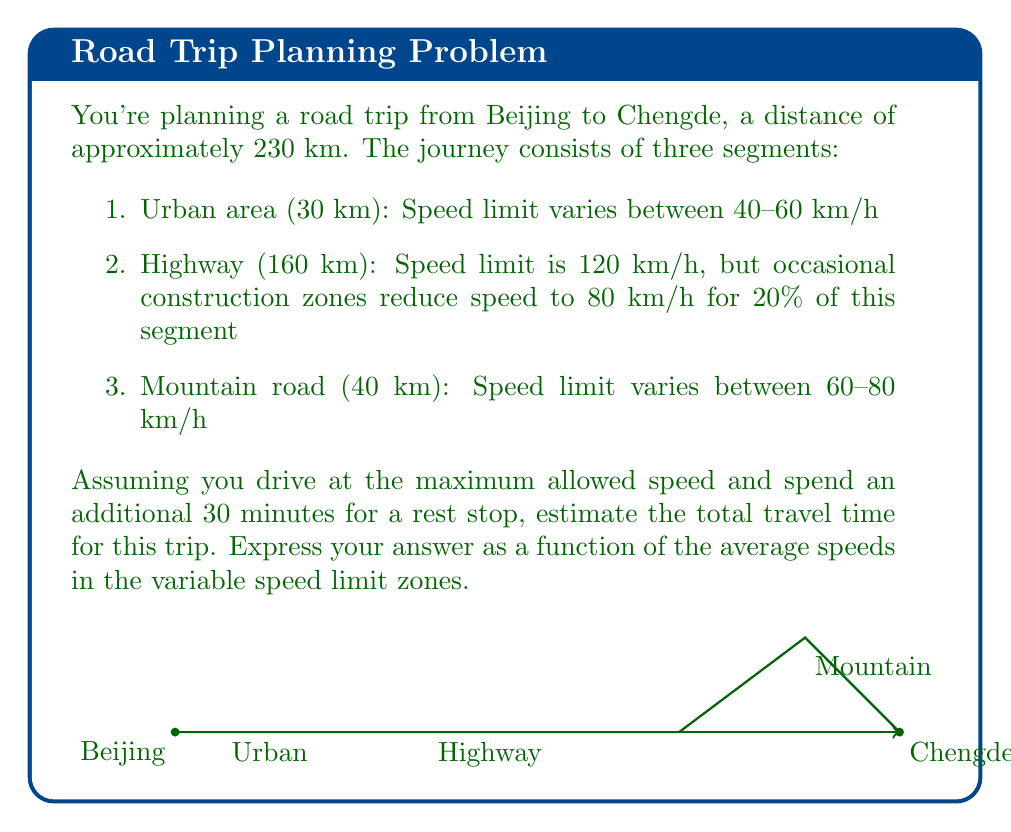Show me your answer to this math problem. Let's approach this problem step-by-step:

1) Let $v_u$ be the average speed in the urban area, and $v_m$ be the average speed on the mountain road.

2) For the urban area (30 km):
   Time = $\frac{30}{v_u}$ hours

3) For the highway (160 km):
   - 80% at 120 km/h: $0.8 \times 160 = 128$ km, Time = $\frac{128}{120} = \frac{16}{15}$ hours
   - 20% at 80 km/h: $0.2 \times 160 = 32$ km, Time = $\frac{32}{80} = \frac{2}{5}$ hours
   Total highway time = $\frac{16}{15} + \frac{2}{5} = \frac{32}{15} + \frac{6}{15} = \frac{38}{15}$ hours

4) For the mountain road (40 km):
   Time = $\frac{40}{v_m}$ hours

5) Rest stop time = 0.5 hours

6) Total travel time $T$ (in hours):

   $$T = \frac{30}{v_u} + \frac{38}{15} + \frac{40}{v_m} + 0.5$$

7) Simplify:
   
   $$T = \frac{30}{v_u} + \frac{40}{v_m} + \frac{53}{15}$$

This is our final function for the total travel time in terms of $v_u$ and $v_m$.
Answer: $$T = \frac{30}{v_u} + \frac{40}{v_m} + \frac{53}{15}$$ 